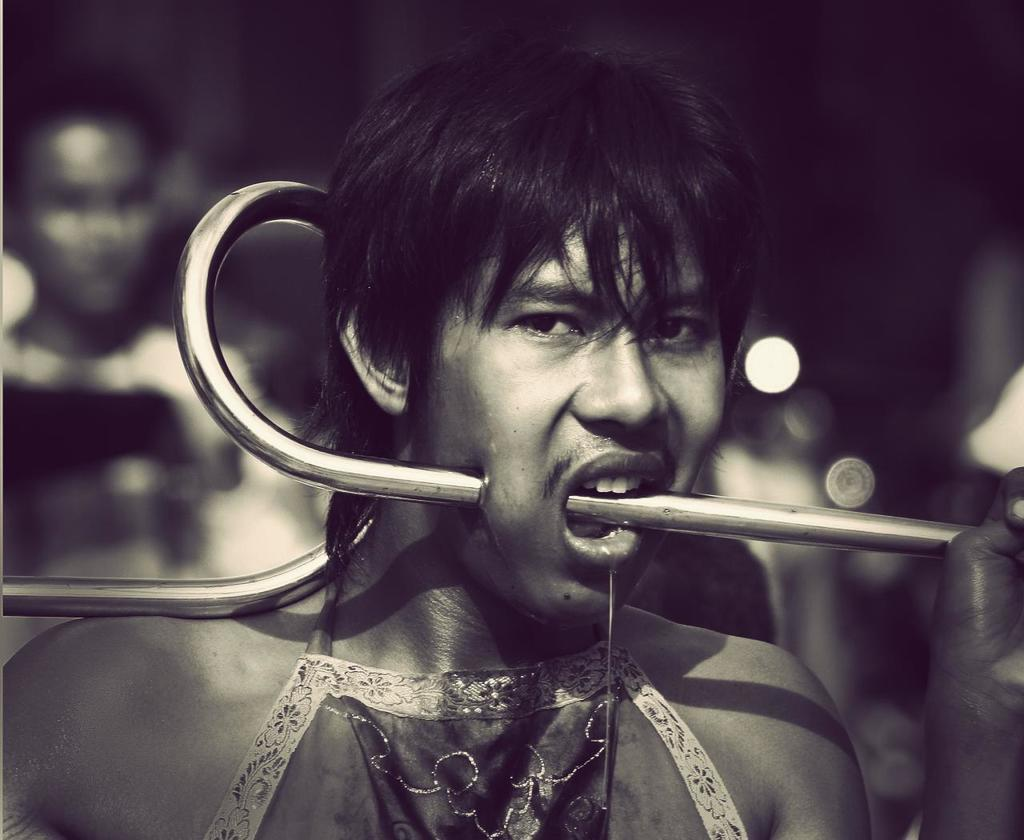What is the main subject of the image? There is a person in the image. What is the person doing in the image? The person has a steel rod in their mouth. Can you describe the background of the image? The background of the image is blurry. How many seats can be seen in the image? There are no seats visible in the image. Is there a flame present in the image? There is no flame present in the image. 